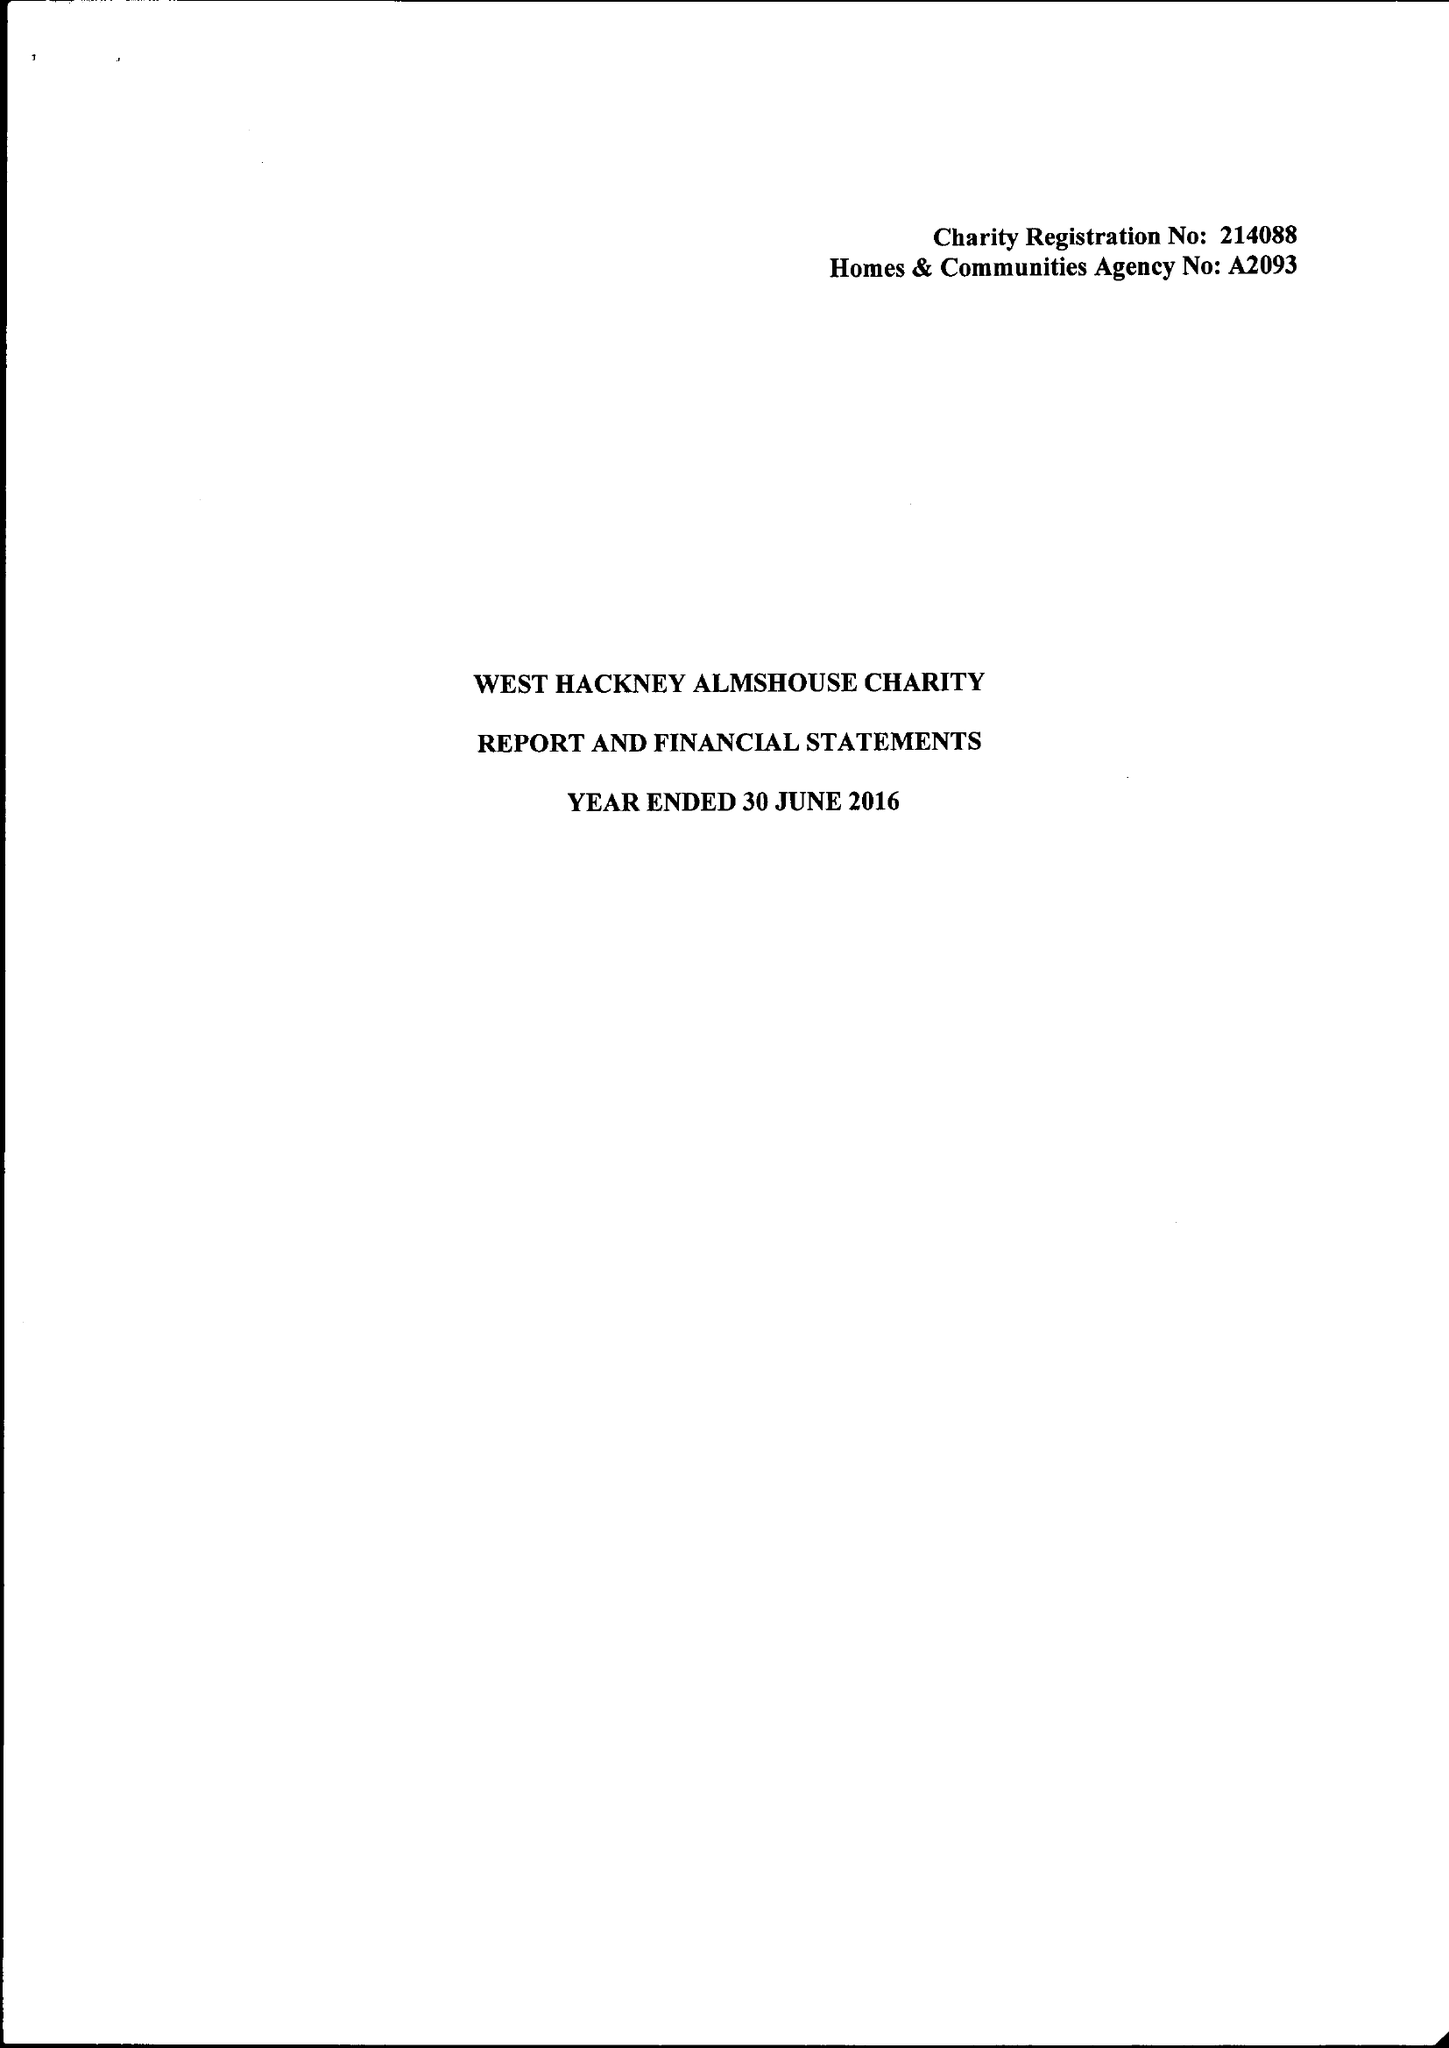What is the value for the charity_name?
Answer the question using a single word or phrase. The West Hackney Almshouse Charity 